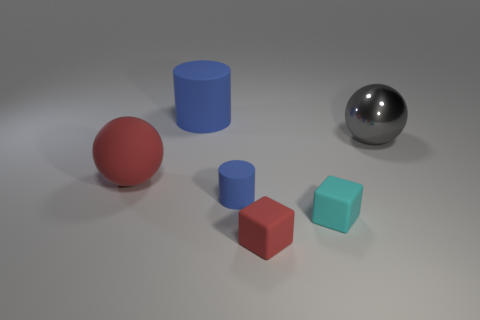Can you describe the lighting in this scene? The scene is illuminated by a soft overhead light source, creating gentle shadows and highlights that suggest an indoor setting with diffused lighting, likely to avoid any harsh reflections. 